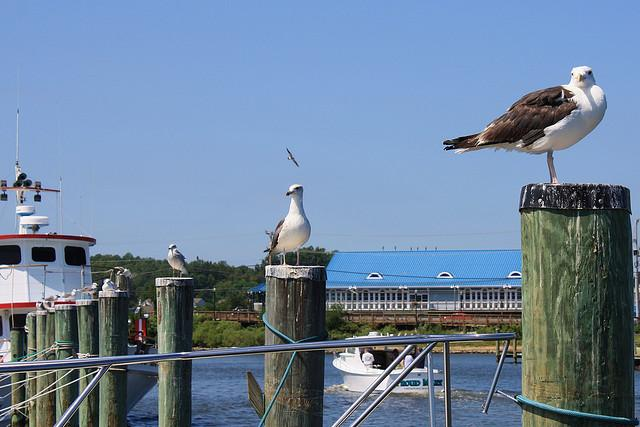What vessels are tied to the piers here? boats 